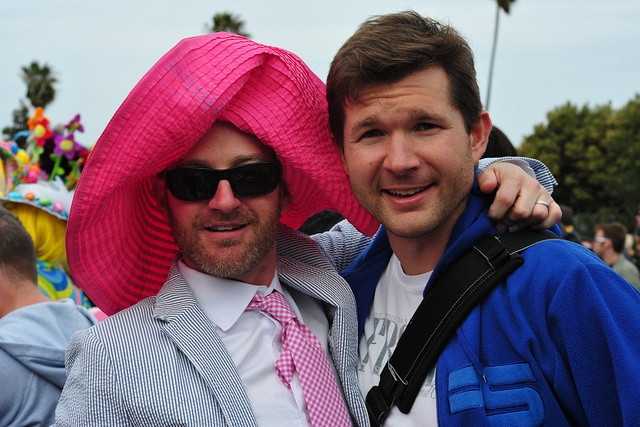Describe the objects in this image and their specific colors. I can see people in lightblue, black, navy, darkblue, and maroon tones, people in lightblue, darkgray, lightgray, black, and maroon tones, people in lightblue, darkgray, and gray tones, backpack in lightblue, black, gray, navy, and darkgray tones, and tie in lightblue and violet tones in this image. 